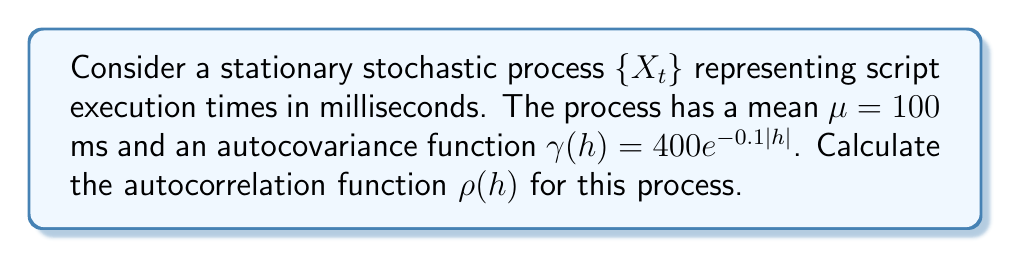Give your solution to this math problem. To compute the autocorrelation function $\rho(h)$ for the given stationary stochastic process, we'll follow these steps:

1. Recall the formula for the autocorrelation function:
   $$\rho(h) = \frac{\gamma(h)}{\gamma(0)}$$
   where $\gamma(h)$ is the autocovariance function and $\gamma(0)$ is the variance of the process.

2. We're given the autocovariance function:
   $$\gamma(h) = 400e^{-0.1|h|}$$

3. To find $\gamma(0)$, we substitute $h=0$ into the autocovariance function:
   $$\gamma(0) = 400e^{-0.1|0|} = 400e^0 = 400$$

4. Now we can compute the autocorrelation function:
   $$\rho(h) = \frac{\gamma(h)}{\gamma(0)} = \frac{400e^{-0.1|h|}}{400} = e^{-0.1|h|}$$

5. This gives us the final form of the autocorrelation function for all lags $h$.
Answer: $\rho(h) = e^{-0.1|h|}$ 